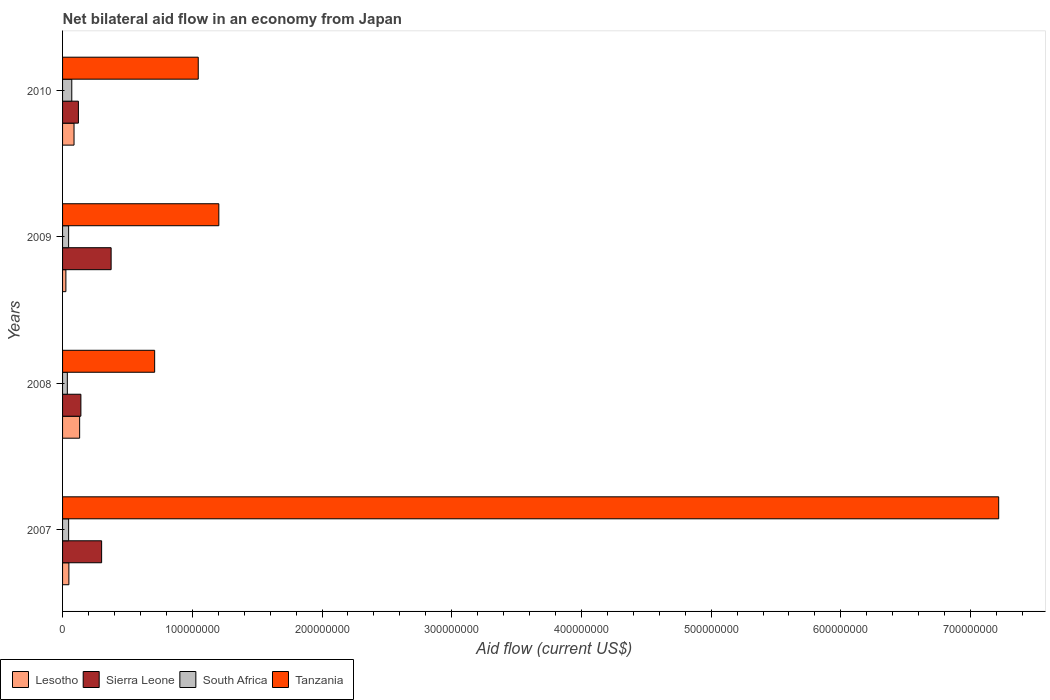Are the number of bars per tick equal to the number of legend labels?
Your answer should be very brief. Yes. Are the number of bars on each tick of the Y-axis equal?
Offer a terse response. Yes. How many bars are there on the 4th tick from the top?
Your response must be concise. 4. How many bars are there on the 4th tick from the bottom?
Your response must be concise. 4. What is the net bilateral aid flow in Lesotho in 2009?
Your answer should be compact. 2.56e+06. Across all years, what is the maximum net bilateral aid flow in Lesotho?
Provide a short and direct response. 1.32e+07. Across all years, what is the minimum net bilateral aid flow in Sierra Leone?
Your answer should be compact. 1.22e+07. In which year was the net bilateral aid flow in Lesotho minimum?
Give a very brief answer. 2009. What is the total net bilateral aid flow in Sierra Leone in the graph?
Give a very brief answer. 9.39e+07. What is the difference between the net bilateral aid flow in Sierra Leone in 2008 and that in 2009?
Give a very brief answer. -2.33e+07. What is the difference between the net bilateral aid flow in South Africa in 2010 and the net bilateral aid flow in Sierra Leone in 2007?
Ensure brevity in your answer.  -2.30e+07. What is the average net bilateral aid flow in Lesotho per year?
Offer a very short reply. 7.36e+06. In the year 2010, what is the difference between the net bilateral aid flow in Tanzania and net bilateral aid flow in South Africa?
Give a very brief answer. 9.75e+07. What is the ratio of the net bilateral aid flow in Sierra Leone in 2007 to that in 2010?
Provide a short and direct response. 2.47. Is the net bilateral aid flow in Tanzania in 2007 less than that in 2010?
Give a very brief answer. No. Is the difference between the net bilateral aid flow in Tanzania in 2007 and 2010 greater than the difference between the net bilateral aid flow in South Africa in 2007 and 2010?
Your answer should be compact. Yes. What is the difference between the highest and the second highest net bilateral aid flow in Sierra Leone?
Give a very brief answer. 7.33e+06. What is the difference between the highest and the lowest net bilateral aid flow in Lesotho?
Provide a succinct answer. 1.06e+07. In how many years, is the net bilateral aid flow in South Africa greater than the average net bilateral aid flow in South Africa taken over all years?
Ensure brevity in your answer.  1. Is it the case that in every year, the sum of the net bilateral aid flow in Lesotho and net bilateral aid flow in South Africa is greater than the sum of net bilateral aid flow in Sierra Leone and net bilateral aid flow in Tanzania?
Provide a short and direct response. No. What does the 1st bar from the top in 2008 represents?
Provide a short and direct response. Tanzania. What does the 2nd bar from the bottom in 2007 represents?
Give a very brief answer. Sierra Leone. How many bars are there?
Offer a terse response. 16. How many years are there in the graph?
Your response must be concise. 4. Does the graph contain any zero values?
Offer a terse response. No. What is the title of the graph?
Your answer should be compact. Net bilateral aid flow in an economy from Japan. Does "Iceland" appear as one of the legend labels in the graph?
Give a very brief answer. No. What is the label or title of the X-axis?
Your answer should be compact. Aid flow (current US$). What is the Aid flow (current US$) in Lesotho in 2007?
Your answer should be compact. 4.88e+06. What is the Aid flow (current US$) of Sierra Leone in 2007?
Offer a very short reply. 3.01e+07. What is the Aid flow (current US$) of South Africa in 2007?
Your answer should be compact. 4.67e+06. What is the Aid flow (current US$) of Tanzania in 2007?
Give a very brief answer. 7.22e+08. What is the Aid flow (current US$) of Lesotho in 2008?
Ensure brevity in your answer.  1.32e+07. What is the Aid flow (current US$) of Sierra Leone in 2008?
Offer a very short reply. 1.41e+07. What is the Aid flow (current US$) of South Africa in 2008?
Offer a terse response. 3.67e+06. What is the Aid flow (current US$) of Tanzania in 2008?
Offer a very short reply. 7.10e+07. What is the Aid flow (current US$) in Lesotho in 2009?
Make the answer very short. 2.56e+06. What is the Aid flow (current US$) in Sierra Leone in 2009?
Make the answer very short. 3.74e+07. What is the Aid flow (current US$) in South Africa in 2009?
Make the answer very short. 4.67e+06. What is the Aid flow (current US$) in Tanzania in 2009?
Your response must be concise. 1.20e+08. What is the Aid flow (current US$) in Lesotho in 2010?
Keep it short and to the point. 8.84e+06. What is the Aid flow (current US$) in Sierra Leone in 2010?
Provide a short and direct response. 1.22e+07. What is the Aid flow (current US$) of South Africa in 2010?
Provide a succinct answer. 7.11e+06. What is the Aid flow (current US$) of Tanzania in 2010?
Ensure brevity in your answer.  1.05e+08. Across all years, what is the maximum Aid flow (current US$) in Lesotho?
Your response must be concise. 1.32e+07. Across all years, what is the maximum Aid flow (current US$) in Sierra Leone?
Keep it short and to the point. 3.74e+07. Across all years, what is the maximum Aid flow (current US$) of South Africa?
Provide a succinct answer. 7.11e+06. Across all years, what is the maximum Aid flow (current US$) in Tanzania?
Your answer should be very brief. 7.22e+08. Across all years, what is the minimum Aid flow (current US$) of Lesotho?
Offer a terse response. 2.56e+06. Across all years, what is the minimum Aid flow (current US$) of Sierra Leone?
Make the answer very short. 1.22e+07. Across all years, what is the minimum Aid flow (current US$) of South Africa?
Your answer should be very brief. 3.67e+06. Across all years, what is the minimum Aid flow (current US$) of Tanzania?
Ensure brevity in your answer.  7.10e+07. What is the total Aid flow (current US$) in Lesotho in the graph?
Your answer should be very brief. 2.94e+07. What is the total Aid flow (current US$) of Sierra Leone in the graph?
Provide a short and direct response. 9.39e+07. What is the total Aid flow (current US$) of South Africa in the graph?
Keep it short and to the point. 2.01e+07. What is the total Aid flow (current US$) in Tanzania in the graph?
Your answer should be compact. 1.02e+09. What is the difference between the Aid flow (current US$) of Lesotho in 2007 and that in 2008?
Ensure brevity in your answer.  -8.28e+06. What is the difference between the Aid flow (current US$) in Sierra Leone in 2007 and that in 2008?
Provide a short and direct response. 1.60e+07. What is the difference between the Aid flow (current US$) of Tanzania in 2007 and that in 2008?
Make the answer very short. 6.51e+08. What is the difference between the Aid flow (current US$) in Lesotho in 2007 and that in 2009?
Provide a short and direct response. 2.32e+06. What is the difference between the Aid flow (current US$) of Sierra Leone in 2007 and that in 2009?
Your response must be concise. -7.33e+06. What is the difference between the Aid flow (current US$) in Tanzania in 2007 and that in 2009?
Give a very brief answer. 6.01e+08. What is the difference between the Aid flow (current US$) of Lesotho in 2007 and that in 2010?
Your response must be concise. -3.96e+06. What is the difference between the Aid flow (current US$) of Sierra Leone in 2007 and that in 2010?
Your answer should be compact. 1.79e+07. What is the difference between the Aid flow (current US$) in South Africa in 2007 and that in 2010?
Provide a short and direct response. -2.44e+06. What is the difference between the Aid flow (current US$) of Tanzania in 2007 and that in 2010?
Provide a succinct answer. 6.17e+08. What is the difference between the Aid flow (current US$) of Lesotho in 2008 and that in 2009?
Ensure brevity in your answer.  1.06e+07. What is the difference between the Aid flow (current US$) in Sierra Leone in 2008 and that in 2009?
Your answer should be compact. -2.33e+07. What is the difference between the Aid flow (current US$) of South Africa in 2008 and that in 2009?
Make the answer very short. -1.00e+06. What is the difference between the Aid flow (current US$) in Tanzania in 2008 and that in 2009?
Ensure brevity in your answer.  -4.95e+07. What is the difference between the Aid flow (current US$) in Lesotho in 2008 and that in 2010?
Offer a terse response. 4.32e+06. What is the difference between the Aid flow (current US$) of Sierra Leone in 2008 and that in 2010?
Offer a terse response. 1.92e+06. What is the difference between the Aid flow (current US$) of South Africa in 2008 and that in 2010?
Keep it short and to the point. -3.44e+06. What is the difference between the Aid flow (current US$) of Tanzania in 2008 and that in 2010?
Your response must be concise. -3.36e+07. What is the difference between the Aid flow (current US$) in Lesotho in 2009 and that in 2010?
Give a very brief answer. -6.28e+06. What is the difference between the Aid flow (current US$) of Sierra Leone in 2009 and that in 2010?
Provide a short and direct response. 2.52e+07. What is the difference between the Aid flow (current US$) of South Africa in 2009 and that in 2010?
Provide a short and direct response. -2.44e+06. What is the difference between the Aid flow (current US$) of Tanzania in 2009 and that in 2010?
Offer a very short reply. 1.59e+07. What is the difference between the Aid flow (current US$) of Lesotho in 2007 and the Aid flow (current US$) of Sierra Leone in 2008?
Offer a terse response. -9.25e+06. What is the difference between the Aid flow (current US$) in Lesotho in 2007 and the Aid flow (current US$) in South Africa in 2008?
Your answer should be compact. 1.21e+06. What is the difference between the Aid flow (current US$) in Lesotho in 2007 and the Aid flow (current US$) in Tanzania in 2008?
Give a very brief answer. -6.61e+07. What is the difference between the Aid flow (current US$) in Sierra Leone in 2007 and the Aid flow (current US$) in South Africa in 2008?
Offer a terse response. 2.64e+07. What is the difference between the Aid flow (current US$) of Sierra Leone in 2007 and the Aid flow (current US$) of Tanzania in 2008?
Provide a succinct answer. -4.09e+07. What is the difference between the Aid flow (current US$) in South Africa in 2007 and the Aid flow (current US$) in Tanzania in 2008?
Your answer should be very brief. -6.63e+07. What is the difference between the Aid flow (current US$) of Lesotho in 2007 and the Aid flow (current US$) of Sierra Leone in 2009?
Provide a succinct answer. -3.26e+07. What is the difference between the Aid flow (current US$) of Lesotho in 2007 and the Aid flow (current US$) of Tanzania in 2009?
Provide a succinct answer. -1.16e+08. What is the difference between the Aid flow (current US$) in Sierra Leone in 2007 and the Aid flow (current US$) in South Africa in 2009?
Ensure brevity in your answer.  2.54e+07. What is the difference between the Aid flow (current US$) of Sierra Leone in 2007 and the Aid flow (current US$) of Tanzania in 2009?
Provide a succinct answer. -9.04e+07. What is the difference between the Aid flow (current US$) in South Africa in 2007 and the Aid flow (current US$) in Tanzania in 2009?
Your answer should be very brief. -1.16e+08. What is the difference between the Aid flow (current US$) in Lesotho in 2007 and the Aid flow (current US$) in Sierra Leone in 2010?
Offer a terse response. -7.33e+06. What is the difference between the Aid flow (current US$) in Lesotho in 2007 and the Aid flow (current US$) in South Africa in 2010?
Keep it short and to the point. -2.23e+06. What is the difference between the Aid flow (current US$) of Lesotho in 2007 and the Aid flow (current US$) of Tanzania in 2010?
Make the answer very short. -9.97e+07. What is the difference between the Aid flow (current US$) of Sierra Leone in 2007 and the Aid flow (current US$) of South Africa in 2010?
Your answer should be compact. 2.30e+07. What is the difference between the Aid flow (current US$) in Sierra Leone in 2007 and the Aid flow (current US$) in Tanzania in 2010?
Your response must be concise. -7.45e+07. What is the difference between the Aid flow (current US$) in South Africa in 2007 and the Aid flow (current US$) in Tanzania in 2010?
Make the answer very short. -9.99e+07. What is the difference between the Aid flow (current US$) in Lesotho in 2008 and the Aid flow (current US$) in Sierra Leone in 2009?
Your answer should be compact. -2.43e+07. What is the difference between the Aid flow (current US$) of Lesotho in 2008 and the Aid flow (current US$) of South Africa in 2009?
Make the answer very short. 8.49e+06. What is the difference between the Aid flow (current US$) in Lesotho in 2008 and the Aid flow (current US$) in Tanzania in 2009?
Keep it short and to the point. -1.07e+08. What is the difference between the Aid flow (current US$) of Sierra Leone in 2008 and the Aid flow (current US$) of South Africa in 2009?
Your answer should be very brief. 9.46e+06. What is the difference between the Aid flow (current US$) of Sierra Leone in 2008 and the Aid flow (current US$) of Tanzania in 2009?
Ensure brevity in your answer.  -1.06e+08. What is the difference between the Aid flow (current US$) of South Africa in 2008 and the Aid flow (current US$) of Tanzania in 2009?
Provide a succinct answer. -1.17e+08. What is the difference between the Aid flow (current US$) of Lesotho in 2008 and the Aid flow (current US$) of Sierra Leone in 2010?
Your answer should be very brief. 9.50e+05. What is the difference between the Aid flow (current US$) of Lesotho in 2008 and the Aid flow (current US$) of South Africa in 2010?
Your response must be concise. 6.05e+06. What is the difference between the Aid flow (current US$) in Lesotho in 2008 and the Aid flow (current US$) in Tanzania in 2010?
Your response must be concise. -9.14e+07. What is the difference between the Aid flow (current US$) in Sierra Leone in 2008 and the Aid flow (current US$) in South Africa in 2010?
Provide a short and direct response. 7.02e+06. What is the difference between the Aid flow (current US$) of Sierra Leone in 2008 and the Aid flow (current US$) of Tanzania in 2010?
Make the answer very short. -9.05e+07. What is the difference between the Aid flow (current US$) in South Africa in 2008 and the Aid flow (current US$) in Tanzania in 2010?
Offer a very short reply. -1.01e+08. What is the difference between the Aid flow (current US$) in Lesotho in 2009 and the Aid flow (current US$) in Sierra Leone in 2010?
Make the answer very short. -9.65e+06. What is the difference between the Aid flow (current US$) of Lesotho in 2009 and the Aid flow (current US$) of South Africa in 2010?
Give a very brief answer. -4.55e+06. What is the difference between the Aid flow (current US$) of Lesotho in 2009 and the Aid flow (current US$) of Tanzania in 2010?
Your answer should be very brief. -1.02e+08. What is the difference between the Aid flow (current US$) of Sierra Leone in 2009 and the Aid flow (current US$) of South Africa in 2010?
Keep it short and to the point. 3.03e+07. What is the difference between the Aid flow (current US$) in Sierra Leone in 2009 and the Aid flow (current US$) in Tanzania in 2010?
Your answer should be very brief. -6.72e+07. What is the difference between the Aid flow (current US$) of South Africa in 2009 and the Aid flow (current US$) of Tanzania in 2010?
Your answer should be very brief. -9.99e+07. What is the average Aid flow (current US$) of Lesotho per year?
Provide a short and direct response. 7.36e+06. What is the average Aid flow (current US$) of Sierra Leone per year?
Your answer should be compact. 2.35e+07. What is the average Aid flow (current US$) in South Africa per year?
Keep it short and to the point. 5.03e+06. What is the average Aid flow (current US$) of Tanzania per year?
Your response must be concise. 2.54e+08. In the year 2007, what is the difference between the Aid flow (current US$) in Lesotho and Aid flow (current US$) in Sierra Leone?
Your answer should be compact. -2.52e+07. In the year 2007, what is the difference between the Aid flow (current US$) of Lesotho and Aid flow (current US$) of South Africa?
Your response must be concise. 2.10e+05. In the year 2007, what is the difference between the Aid flow (current US$) of Lesotho and Aid flow (current US$) of Tanzania?
Keep it short and to the point. -7.17e+08. In the year 2007, what is the difference between the Aid flow (current US$) in Sierra Leone and Aid flow (current US$) in South Africa?
Provide a short and direct response. 2.54e+07. In the year 2007, what is the difference between the Aid flow (current US$) in Sierra Leone and Aid flow (current US$) in Tanzania?
Your answer should be compact. -6.92e+08. In the year 2007, what is the difference between the Aid flow (current US$) in South Africa and Aid flow (current US$) in Tanzania?
Provide a short and direct response. -7.17e+08. In the year 2008, what is the difference between the Aid flow (current US$) in Lesotho and Aid flow (current US$) in Sierra Leone?
Offer a very short reply. -9.70e+05. In the year 2008, what is the difference between the Aid flow (current US$) of Lesotho and Aid flow (current US$) of South Africa?
Offer a terse response. 9.49e+06. In the year 2008, what is the difference between the Aid flow (current US$) of Lesotho and Aid flow (current US$) of Tanzania?
Make the answer very short. -5.78e+07. In the year 2008, what is the difference between the Aid flow (current US$) of Sierra Leone and Aid flow (current US$) of South Africa?
Provide a succinct answer. 1.05e+07. In the year 2008, what is the difference between the Aid flow (current US$) in Sierra Leone and Aid flow (current US$) in Tanzania?
Make the answer very short. -5.69e+07. In the year 2008, what is the difference between the Aid flow (current US$) of South Africa and Aid flow (current US$) of Tanzania?
Keep it short and to the point. -6.73e+07. In the year 2009, what is the difference between the Aid flow (current US$) of Lesotho and Aid flow (current US$) of Sierra Leone?
Make the answer very short. -3.49e+07. In the year 2009, what is the difference between the Aid flow (current US$) of Lesotho and Aid flow (current US$) of South Africa?
Your answer should be compact. -2.11e+06. In the year 2009, what is the difference between the Aid flow (current US$) of Lesotho and Aid flow (current US$) of Tanzania?
Provide a succinct answer. -1.18e+08. In the year 2009, what is the difference between the Aid flow (current US$) of Sierra Leone and Aid flow (current US$) of South Africa?
Your response must be concise. 3.28e+07. In the year 2009, what is the difference between the Aid flow (current US$) of Sierra Leone and Aid flow (current US$) of Tanzania?
Offer a very short reply. -8.30e+07. In the year 2009, what is the difference between the Aid flow (current US$) of South Africa and Aid flow (current US$) of Tanzania?
Your answer should be very brief. -1.16e+08. In the year 2010, what is the difference between the Aid flow (current US$) of Lesotho and Aid flow (current US$) of Sierra Leone?
Offer a very short reply. -3.37e+06. In the year 2010, what is the difference between the Aid flow (current US$) of Lesotho and Aid flow (current US$) of South Africa?
Make the answer very short. 1.73e+06. In the year 2010, what is the difference between the Aid flow (current US$) of Lesotho and Aid flow (current US$) of Tanzania?
Offer a very short reply. -9.58e+07. In the year 2010, what is the difference between the Aid flow (current US$) in Sierra Leone and Aid flow (current US$) in South Africa?
Your response must be concise. 5.10e+06. In the year 2010, what is the difference between the Aid flow (current US$) in Sierra Leone and Aid flow (current US$) in Tanzania?
Keep it short and to the point. -9.24e+07. In the year 2010, what is the difference between the Aid flow (current US$) of South Africa and Aid flow (current US$) of Tanzania?
Provide a succinct answer. -9.75e+07. What is the ratio of the Aid flow (current US$) of Lesotho in 2007 to that in 2008?
Offer a terse response. 0.37. What is the ratio of the Aid flow (current US$) of Sierra Leone in 2007 to that in 2008?
Give a very brief answer. 2.13. What is the ratio of the Aid flow (current US$) of South Africa in 2007 to that in 2008?
Offer a terse response. 1.27. What is the ratio of the Aid flow (current US$) of Tanzania in 2007 to that in 2008?
Make the answer very short. 10.17. What is the ratio of the Aid flow (current US$) of Lesotho in 2007 to that in 2009?
Ensure brevity in your answer.  1.91. What is the ratio of the Aid flow (current US$) in Sierra Leone in 2007 to that in 2009?
Ensure brevity in your answer.  0.8. What is the ratio of the Aid flow (current US$) of South Africa in 2007 to that in 2009?
Offer a very short reply. 1. What is the ratio of the Aid flow (current US$) of Tanzania in 2007 to that in 2009?
Give a very brief answer. 5.99. What is the ratio of the Aid flow (current US$) in Lesotho in 2007 to that in 2010?
Your answer should be very brief. 0.55. What is the ratio of the Aid flow (current US$) in Sierra Leone in 2007 to that in 2010?
Ensure brevity in your answer.  2.47. What is the ratio of the Aid flow (current US$) of South Africa in 2007 to that in 2010?
Offer a very short reply. 0.66. What is the ratio of the Aid flow (current US$) of Tanzania in 2007 to that in 2010?
Your answer should be compact. 6.9. What is the ratio of the Aid flow (current US$) of Lesotho in 2008 to that in 2009?
Ensure brevity in your answer.  5.14. What is the ratio of the Aid flow (current US$) in Sierra Leone in 2008 to that in 2009?
Ensure brevity in your answer.  0.38. What is the ratio of the Aid flow (current US$) in South Africa in 2008 to that in 2009?
Make the answer very short. 0.79. What is the ratio of the Aid flow (current US$) of Tanzania in 2008 to that in 2009?
Your answer should be compact. 0.59. What is the ratio of the Aid flow (current US$) in Lesotho in 2008 to that in 2010?
Your answer should be compact. 1.49. What is the ratio of the Aid flow (current US$) of Sierra Leone in 2008 to that in 2010?
Give a very brief answer. 1.16. What is the ratio of the Aid flow (current US$) in South Africa in 2008 to that in 2010?
Your answer should be very brief. 0.52. What is the ratio of the Aid flow (current US$) of Tanzania in 2008 to that in 2010?
Offer a terse response. 0.68. What is the ratio of the Aid flow (current US$) in Lesotho in 2009 to that in 2010?
Provide a short and direct response. 0.29. What is the ratio of the Aid flow (current US$) of Sierra Leone in 2009 to that in 2010?
Provide a succinct answer. 3.07. What is the ratio of the Aid flow (current US$) of South Africa in 2009 to that in 2010?
Provide a short and direct response. 0.66. What is the ratio of the Aid flow (current US$) of Tanzania in 2009 to that in 2010?
Provide a succinct answer. 1.15. What is the difference between the highest and the second highest Aid flow (current US$) of Lesotho?
Offer a very short reply. 4.32e+06. What is the difference between the highest and the second highest Aid flow (current US$) of Sierra Leone?
Provide a succinct answer. 7.33e+06. What is the difference between the highest and the second highest Aid flow (current US$) in South Africa?
Provide a succinct answer. 2.44e+06. What is the difference between the highest and the second highest Aid flow (current US$) in Tanzania?
Your answer should be very brief. 6.01e+08. What is the difference between the highest and the lowest Aid flow (current US$) in Lesotho?
Give a very brief answer. 1.06e+07. What is the difference between the highest and the lowest Aid flow (current US$) of Sierra Leone?
Offer a terse response. 2.52e+07. What is the difference between the highest and the lowest Aid flow (current US$) of South Africa?
Give a very brief answer. 3.44e+06. What is the difference between the highest and the lowest Aid flow (current US$) in Tanzania?
Make the answer very short. 6.51e+08. 